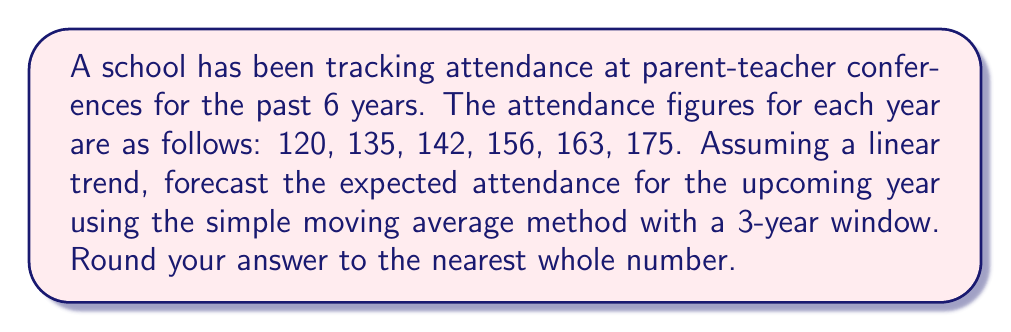Help me with this question. To forecast the attendance for the upcoming year using the simple moving average method with a 3-year window, we'll follow these steps:

1. Calculate the 3-year moving averages:
   For years 3-5: $\frac{120 + 135 + 142}{3} = 132.33$
   For years 4-6: $\frac{135 + 142 + 156}{3} = 144.33$
   For years 5-7: $\frac{142 + 156 + 163}{3} = 153.67$
   For years 6-8: $\frac{156 + 163 + 175}{3} = 164.67$

2. Calculate the average increase between consecutive moving averages:
   $\frac{(144.33 - 132.33) + (153.67 - 144.33) + (164.67 - 153.67)}{3} = 10.78$

3. Add this average increase to the last moving average to forecast the next year:
   $164.67 + 10.78 = 175.45$

4. Round to the nearest whole number:
   $175.45 \approx 175$

The simple moving average method assumes that the trend observed in the past will continue in the future, which aligns with the linear trend assumption in the question.
Answer: 175 